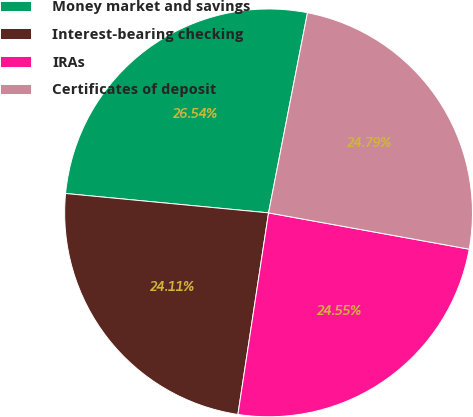<chart> <loc_0><loc_0><loc_500><loc_500><pie_chart><fcel>Money market and savings<fcel>Interest-bearing checking<fcel>IRAs<fcel>Certificates of deposit<nl><fcel>26.54%<fcel>24.11%<fcel>24.55%<fcel>24.79%<nl></chart> 